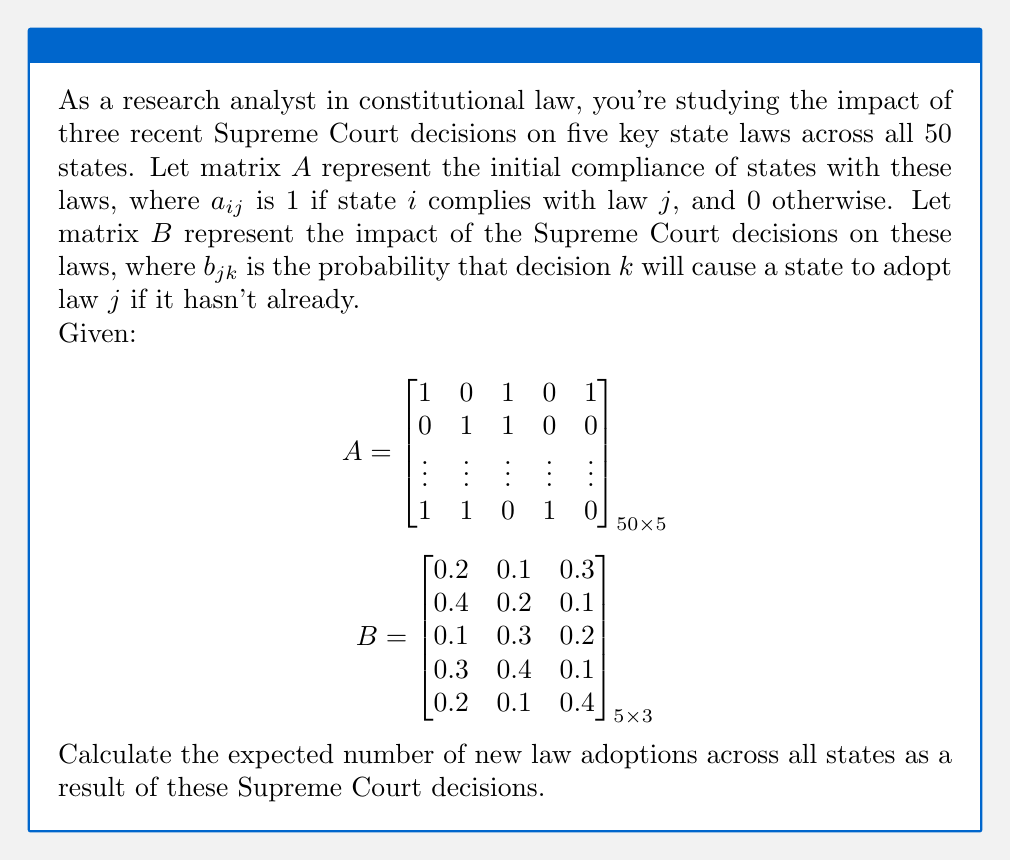What is the answer to this math problem? To solve this problem, we'll follow these steps:

1) First, we need to understand what $AB$ represents. Each element $(AB)_{ij}$ will give the probability that state $i$ will adopt new laws due to decision $j$, considering its current compliance status.

2) However, we're only interested in new adoptions. So we need to calculate $C = (1-A)B$, where $(1-A)$ is the complement of $A$. This ensures we only count probabilities for laws not already adopted.

3) The sum of all elements in $C$ will give us the expected total number of new law adoptions across all states.

Let's calculate:

$$C = (1-A)B$$

$(1-A)$ is a $50 \times 5$ matrix where each element is the opposite of $A$'s corresponding element (0 becomes 1 and vice versa).

Multiplying this by $B$ (which is $5 \times 3$) will result in a $50 \times 3$ matrix $C$.

4) Each element $c_{ij}$ in $C$ represents the probability that state $i$ will adopt a new law due to decision $j$.

5) The sum of all elements in $C$, $\sum_{i=1}^{50}\sum_{j=1}^{3} c_{ij}$, gives us the expected total number of new law adoptions.

While we can't perform the exact calculation without the full $A$ matrix, we can express the answer in terms of this sum.
Answer: $\sum_{i=1}^{50}\sum_{j=1}^{3} c_{ij}$, where $C = (1-A)B$ 